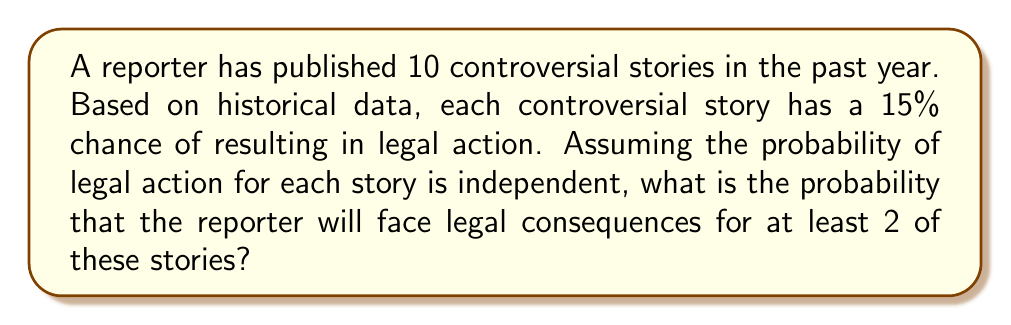Can you answer this question? To solve this problem, we'll use the binomial probability distribution and the complement rule.

1) Let X be the number of stories that result in legal action.
   X follows a binomial distribution with n = 10 (number of stories) and p = 0.15 (probability of legal action for each story).

2) We want to find P(X ≥ 2), which is equivalent to 1 - P(X < 2) or 1 - [P(X = 0) + P(X = 1)].

3) The probability mass function for a binomial distribution is:

   $$P(X = k) = \binom{n}{k} p^k (1-p)^{n-k}$$

4) Calculate P(X = 0):
   $$P(X = 0) = \binom{10}{0} (0.15)^0 (0.85)^{10} = 1 \cdot 1 \cdot 0.85^{10} \approx 0.1969$$

5) Calculate P(X = 1):
   $$P(X = 1) = \binom{10}{1} (0.15)^1 (0.85)^9 = 10 \cdot 0.15 \cdot 0.85^9 \approx 0.3474$$

6) Now, we can calculate P(X ≥ 2):
   $$P(X \geq 2) = 1 - [P(X = 0) + P(X = 1)]$$
   $$P(X \geq 2) = 1 - (0.1969 + 0.3474) = 1 - 0.5443 \approx 0.4557$$

Therefore, the probability of facing legal consequences for at least 2 out of the 10 controversial stories is approximately 0.4557 or 45.57%.
Answer: 0.4557 or 45.57% 